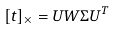<formula> <loc_0><loc_0><loc_500><loc_500>[ t ] _ { \times } = U W \Sigma U ^ { T }</formula> 